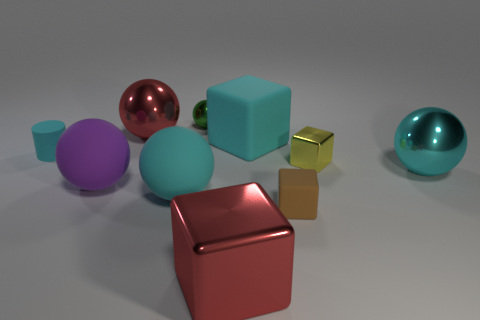There is a large sphere behind the big cyan block; is its color the same as the metal sphere that is in front of the small cyan rubber cylinder?
Provide a short and direct response. No. Are there fewer brown objects that are in front of the large red metal block than tiny purple balls?
Offer a very short reply. No. How many things are large matte cylinders or shiny spheres that are left of the cyan cube?
Offer a very short reply. 2. The other cube that is the same material as the tiny yellow cube is what color?
Your response must be concise. Red. How many things are big yellow objects or small balls?
Provide a short and direct response. 1. There is a metal block that is the same size as the purple object; what color is it?
Offer a very short reply. Red. How many objects are cyan objects that are behind the tiny yellow metallic thing or tiny metal spheres?
Offer a very short reply. 3. How many other objects are there of the same size as the purple thing?
Provide a short and direct response. 5. What is the size of the metal thing that is to the left of the small green metal object?
Your answer should be very brief. Large. There is a tiny thing that is made of the same material as the cyan cylinder; what is its shape?
Provide a succinct answer. Cube. 